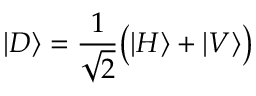Convert formula to latex. <formula><loc_0><loc_0><loc_500><loc_500>| D \rangle = { \frac { 1 } { \sqrt { 2 } } } { \left ( } | H \rangle + | V \rangle { \right ) }</formula> 